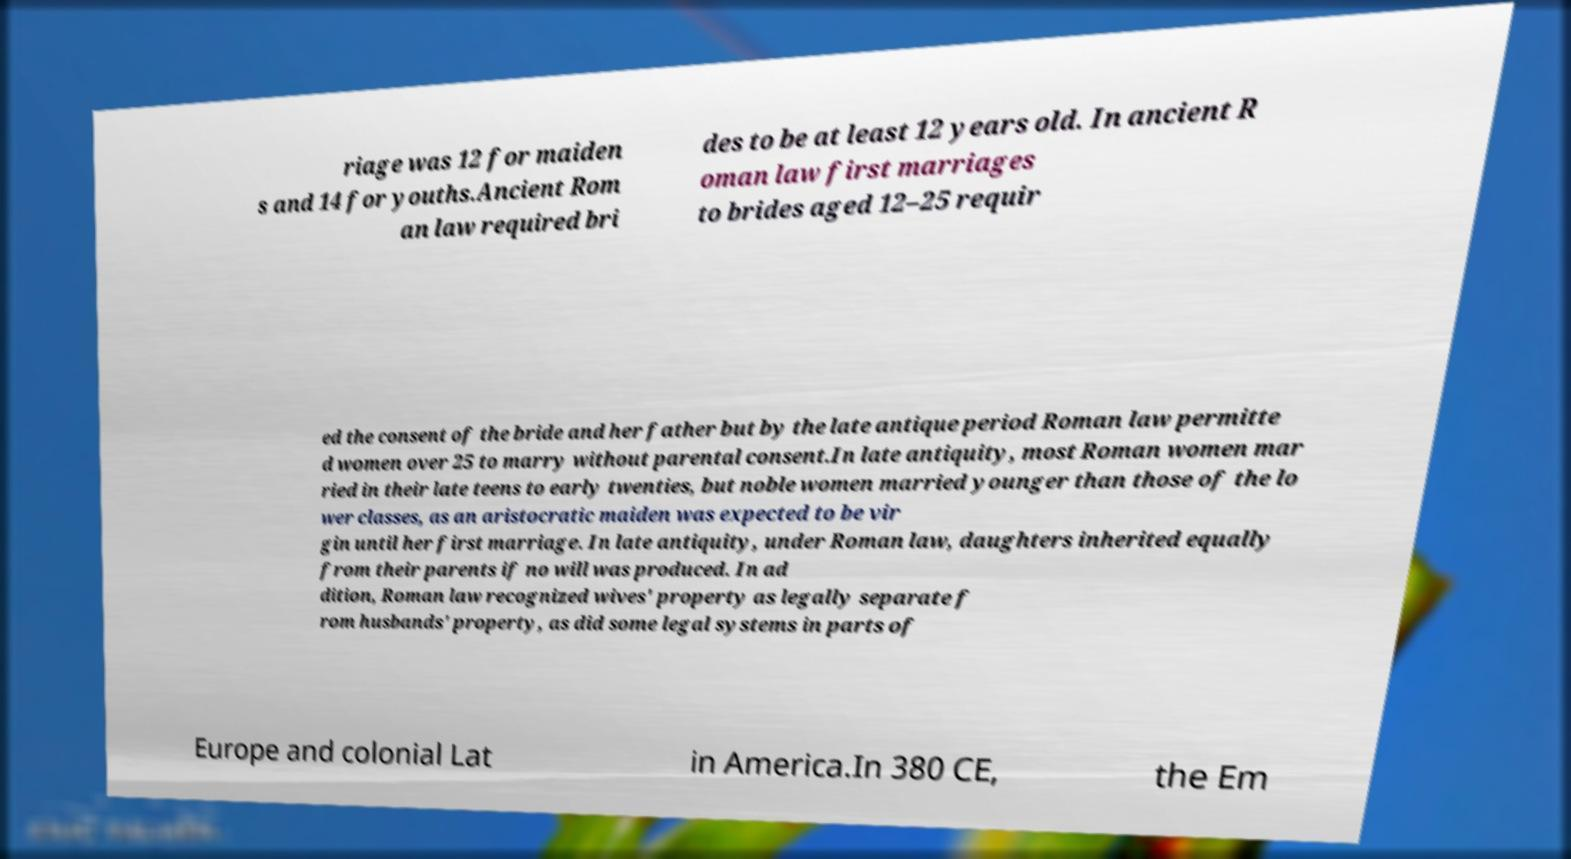Please read and relay the text visible in this image. What does it say? riage was 12 for maiden s and 14 for youths.Ancient Rom an law required bri des to be at least 12 years old. In ancient R oman law first marriages to brides aged 12–25 requir ed the consent of the bride and her father but by the late antique period Roman law permitte d women over 25 to marry without parental consent.In late antiquity, most Roman women mar ried in their late teens to early twenties, but noble women married younger than those of the lo wer classes, as an aristocratic maiden was expected to be vir gin until her first marriage. In late antiquity, under Roman law, daughters inherited equally from their parents if no will was produced. In ad dition, Roman law recognized wives' property as legally separate f rom husbands' property, as did some legal systems in parts of Europe and colonial Lat in America.In 380 CE, the Em 